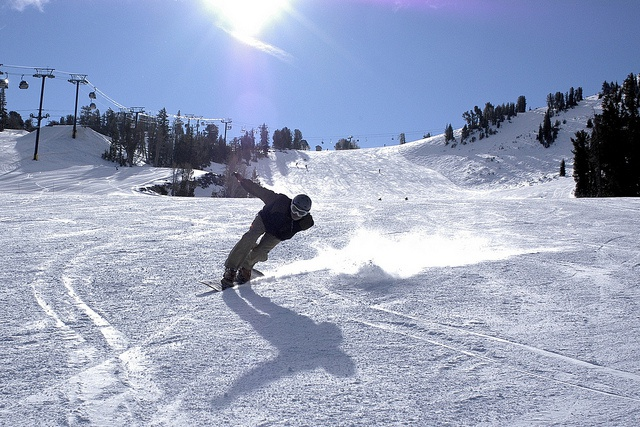Describe the objects in this image and their specific colors. I can see people in gray and black tones and snowboard in gray, darkgray, and lightgray tones in this image. 